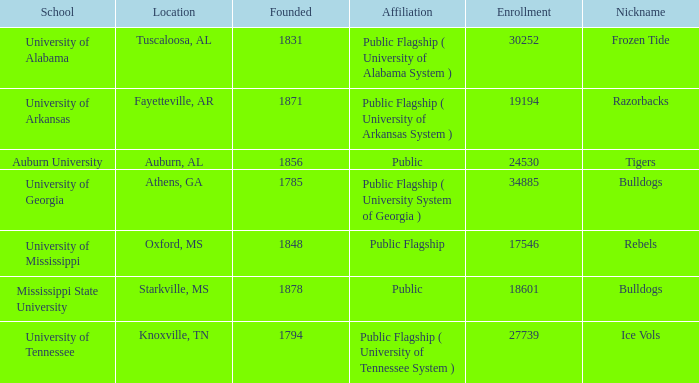What is the upper limit of student intake for the schools? 34885.0. 